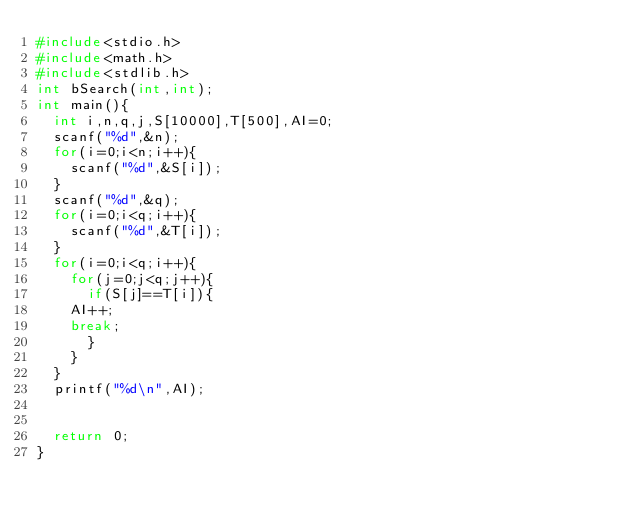<code> <loc_0><loc_0><loc_500><loc_500><_C_>#include<stdio.h>
#include<math.h>
#include<stdlib.h>
int bSearch(int,int); 
int main(){
  int i,n,q,j,S[10000],T[500],AI=0;
  scanf("%d",&n);
  for(i=0;i<n;i++){
    scanf("%d",&S[i]);
  }
  scanf("%d",&q);
  for(i=0;i<q;i++){
    scanf("%d",&T[i]);
  }
  for(i=0;i<q;i++){
    for(j=0;j<q;j++){
      if(S[j]==T[i]){
	AI++;
	break;
      }
    }
  }
  printf("%d\n",AI);
  
  
  return 0;
}</code> 